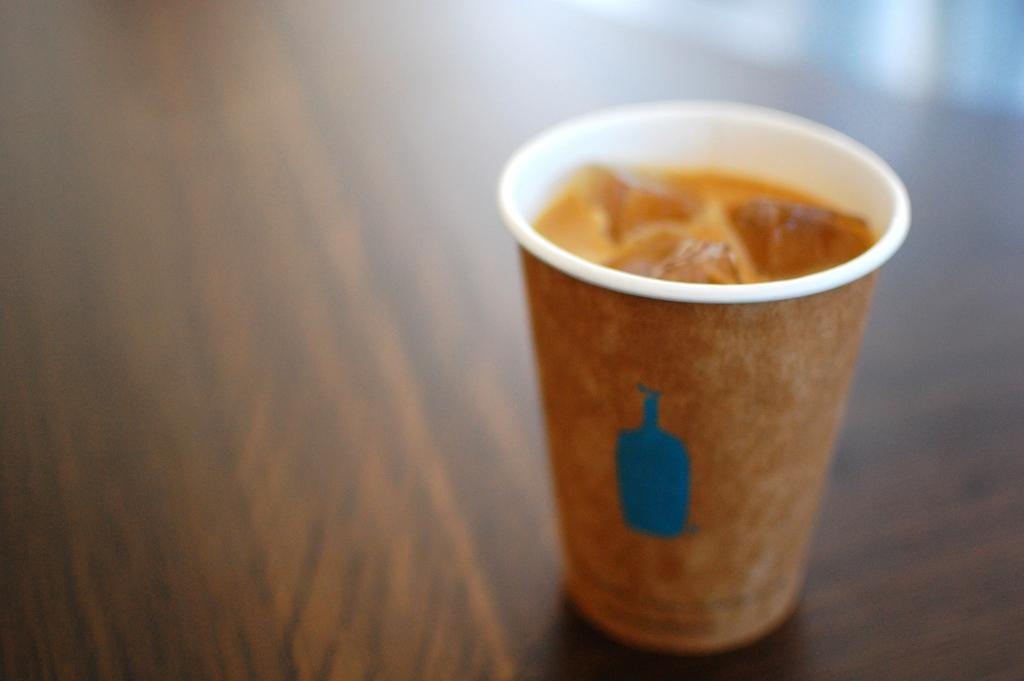What object is visible in the image? There is a cup in the image. Where is the cup located? The cup is placed on a table. What is the color of the table? The table is brown in color. Can you describe the background of the image? The background of the image is blurred. What direction is the water flowing in the image? There is no water present in the image, so it is not possible to determine the direction of water flow. 